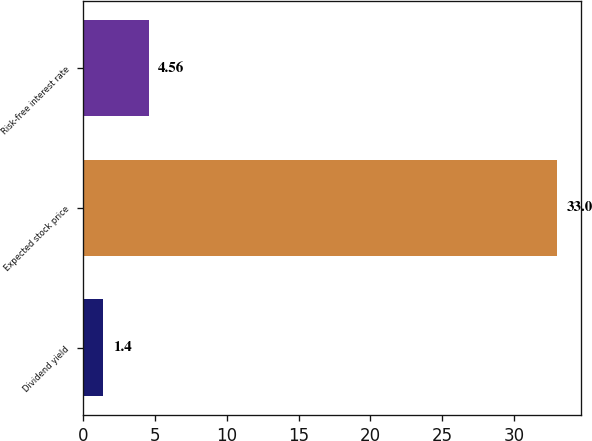Convert chart. <chart><loc_0><loc_0><loc_500><loc_500><bar_chart><fcel>Dividend yield<fcel>Expected stock price<fcel>Risk-free interest rate<nl><fcel>1.4<fcel>33<fcel>4.56<nl></chart> 